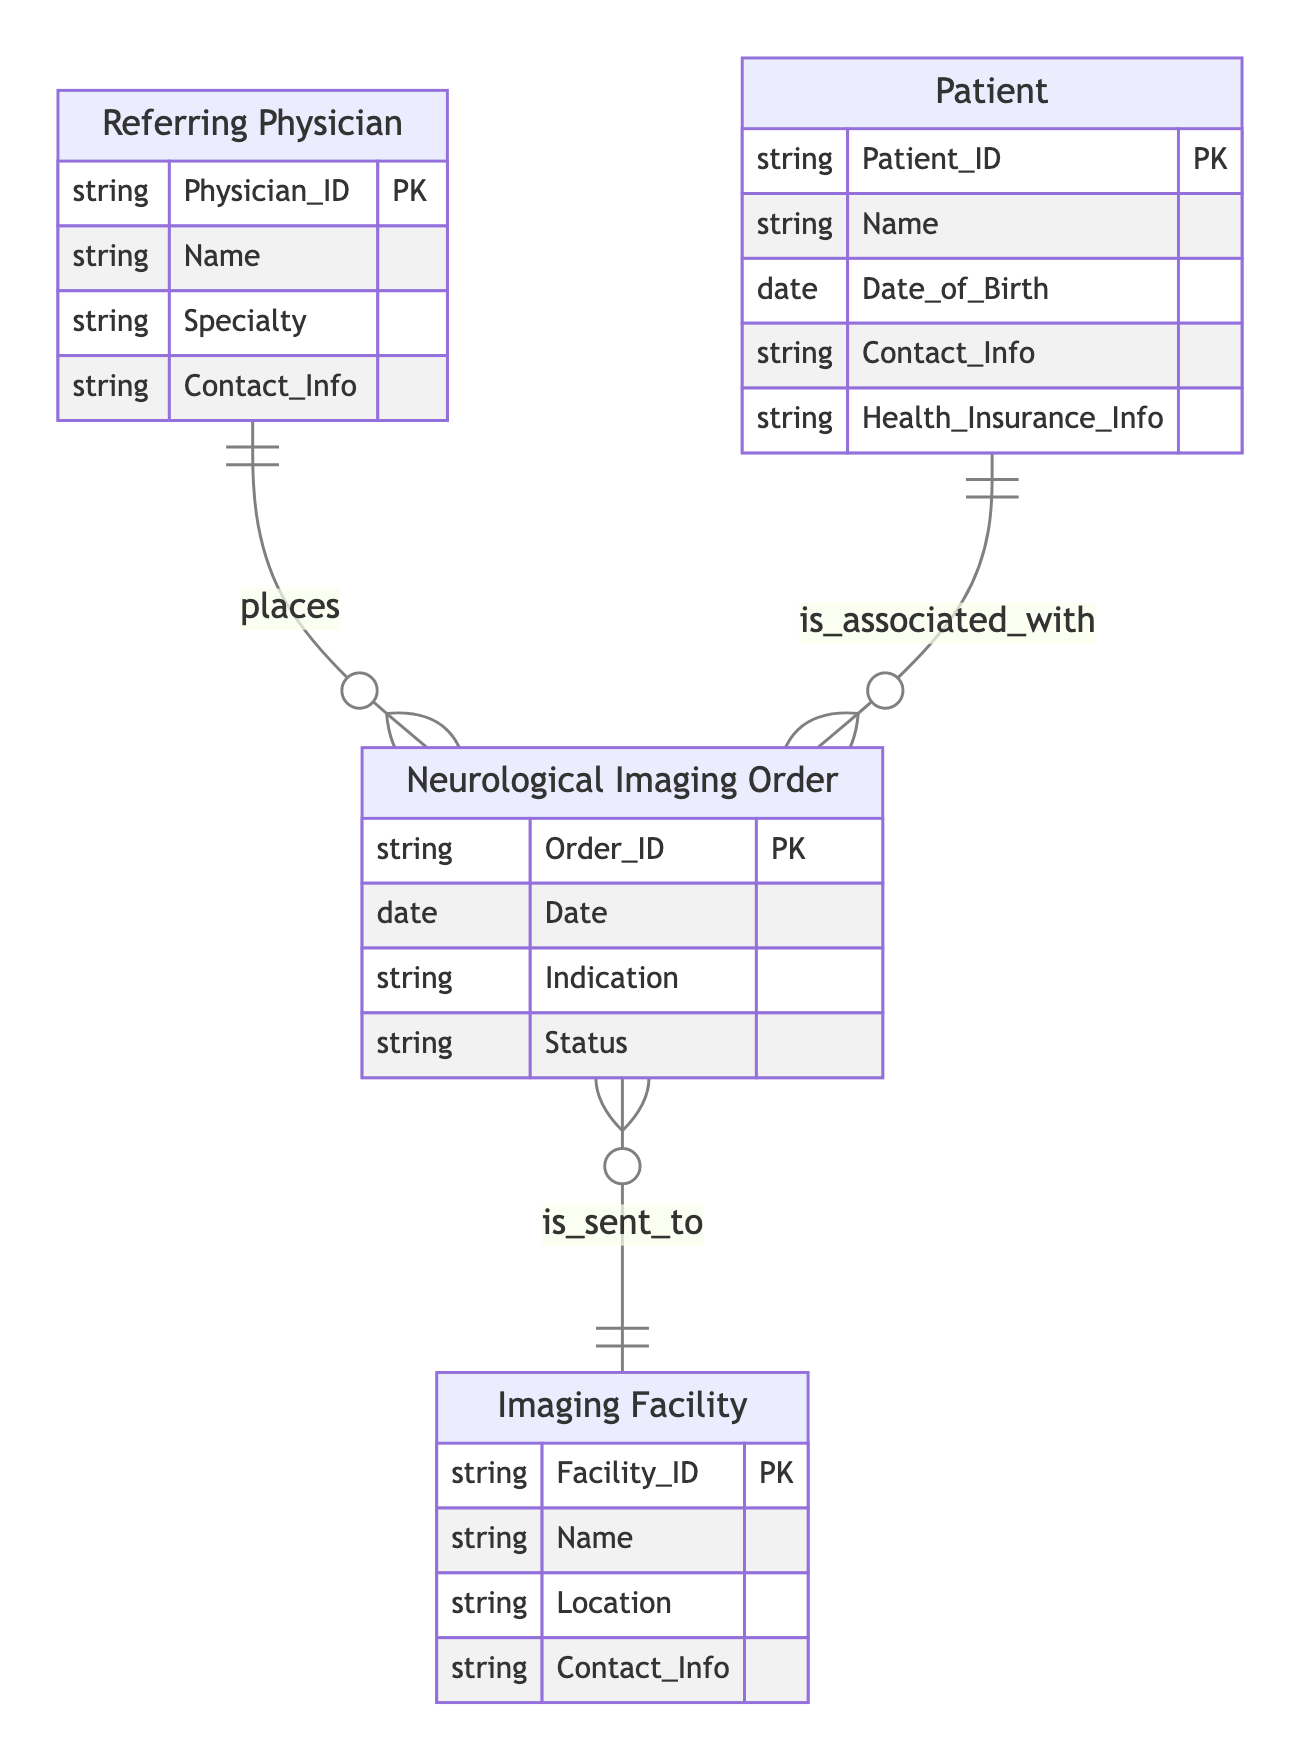What entities are present in the diagram? The diagram contains four entities: Referring Physician, Patient, Imaging Facility, and Neurological Imaging Order. Each entity is defined by a set of attributes, and they are visually represented in the diagram.
Answer: Referring Physician, Patient, Imaging Facility, Neurological Imaging Order How many relationships are there in the diagram? There are three relationships in the diagram: Referring Physician places Neurological Imaging Order, Patient is associated with Neurological Imaging Order, and Neurological Imaging Order is sent to Imaging Facility. Counting each relationship gives us the total.
Answer: 3 What is the relationship type between Referring Physician and Neurological Imaging Order? The relationship between Referring Physician and Neurological Imaging Order is described as "places," indicating that referring physicians create or submit imaging orders. This is explicitly shown in the diagram's connections.
Answer: places Which entity is linked to the Imaging Facility? The entity linked to the Imaging Facility is Neurological Imaging Order, indicating that orders are sent to imaging facilities for processing. This relationship showcases the process flow of the imaging referrals.
Answer: Neurological Imaging Order Which attribute of the Patient entity is used for identification? The Patient entity uses Patient_ID as the primary key for identification, as indicated in the diagram where each entity is marked with a unique identifier, allowing for clear data management and retrieval.
Answer: Patient_ID What does the "is_associated_with" relationship signify? The "is_associated_with" relationship signifies that a Patient can have multiple Neurological Imaging Orders linked to them. This relationship shows how patients are connected to specific imaging orders they have received, reflecting a direct association.
Answer: Multiple orders How many attributes does the Imaging Facility have? The Imaging Facility has four attributes: Facility_ID, Name, Location, and Contact_Info. Counting these provides the total number of attributes defining the Imaging Facility in the diagram.
Answer: 4 What is the Status attribute associated with in the diagram? The Status attribute is associated with Neurological Imaging Order, indicating the current state of the order, such as whether it is pending, completed, or another status. This relationship is outlined by the attributes listed for the Neurological Imaging Order entity.
Answer: Neurological Imaging Order How many entities have a direct relationship with the Neurological Imaging Order? Two entities have a direct relationship with Neurological Imaging Order: Referring Physician and Patient. Both are linked through different relationship types, illustrating their involvement in the imaging order process.
Answer: 2 What does the line connecting Imaging Facility to Neurological Imaging Order indicate? The line indicates that Neurological Imaging Orders are sent to the Imaging Facility, representing a transfer of information or tasks from the order to the facility responsible for performing the imaging procedures.
Answer: is sent to 